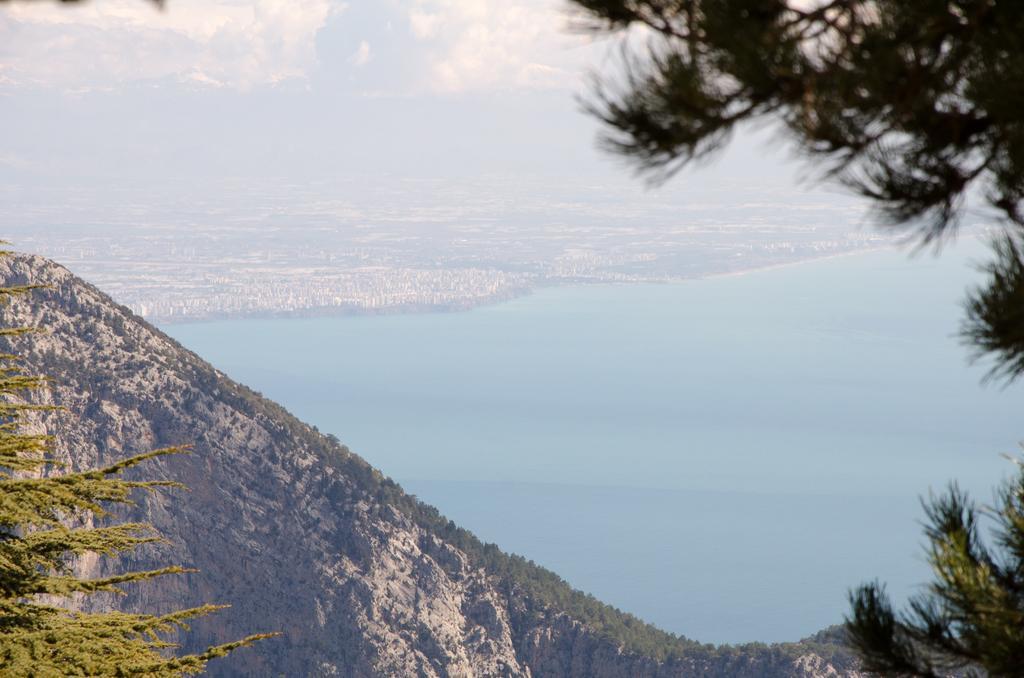Can you describe this image briefly? In this picture we can observe some trees and a hill. We can observe an ocean. In the background there is a sky with some clouds. 